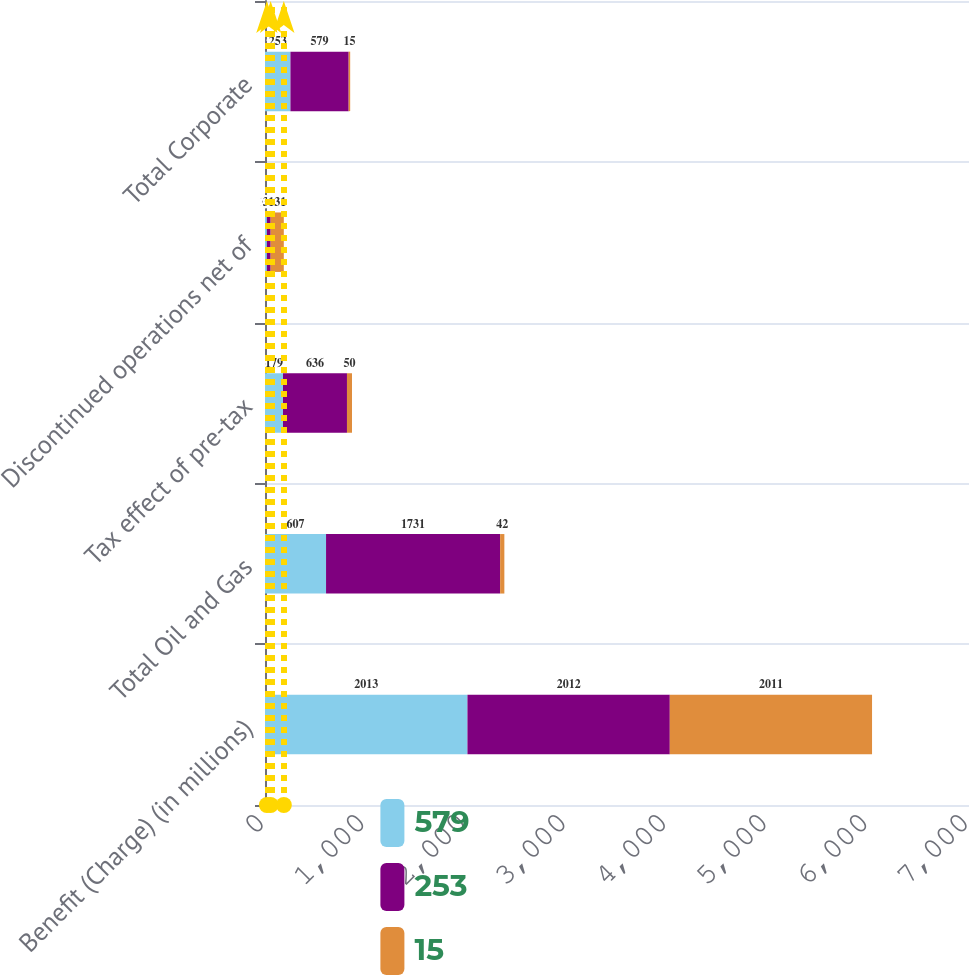Convert chart. <chart><loc_0><loc_0><loc_500><loc_500><stacked_bar_chart><ecel><fcel>Benefit (Charge) (in millions)<fcel>Total Oil and Gas<fcel>Tax effect of pre-tax<fcel>Discontinued operations net of<fcel>Total Corporate<nl><fcel>579<fcel>2013<fcel>607<fcel>179<fcel>19<fcel>253<nl><fcel>253<fcel>2012<fcel>1731<fcel>636<fcel>37<fcel>579<nl><fcel>15<fcel>2011<fcel>42<fcel>50<fcel>131<fcel>15<nl></chart> 